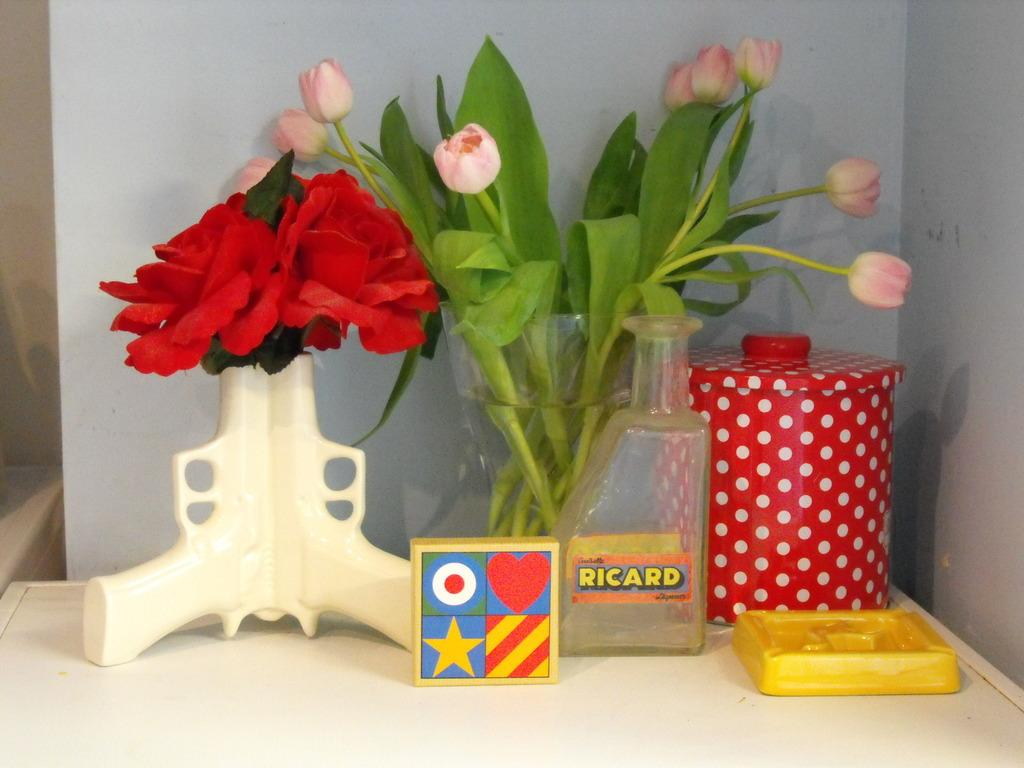What objects are on the table in the image? There are flower vases, a bottle, a jar, a box, and a board on the table in the image. What is the background of the image? There is a wall in the background of the image. What type of machine is visible on the table in the image? There is no machine present on the table in the image. What color is the yak standing next to the wall in the image? There is no yak present in the image; it only features objects on the table and a wall in the background. 